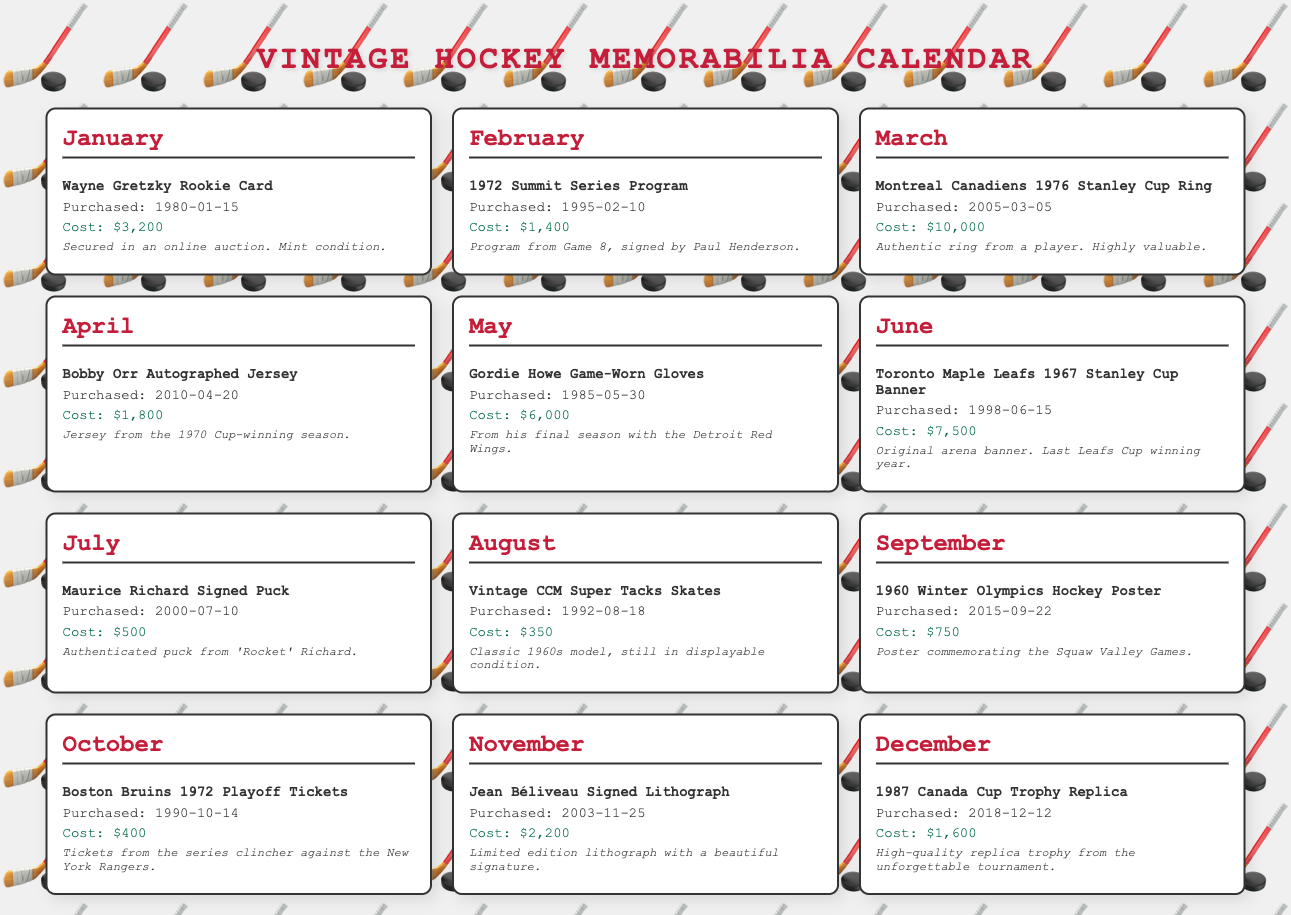What is the most expensive item purchased? The document lists the prices for each item, with the most expensive being the Montreal Canadiens 1976 Stanley Cup Ring for $10,000.
Answer: $10,000 When was the Wayne Gretzky Rookie Card purchased? The document specifies the purchase date for each item; the Wayne Gretzky Rookie Card was purchased on 1980-01-15.
Answer: 1980-01-15 How much did the Gordie Howe Game-Worn Gloves cost? The cost of the Gordie Howe Game-Worn Gloves is explicitly stated in the document as $6,000.
Answer: $6,000 Which month features the Bobby Orr Autographed Jersey? Each item is listed under a specific month; the Bobby Orr Autographed Jersey is in April.
Answer: April What is the total cost of all memorabilia purchased in June? The document presents only one item for June, which is the Toronto Maple Leafs 1967 Stanley Cup Banner costing $7,500, thus no total to calculate.
Answer: $7,500 Which memorabilia item was signed by Paul Henderson? The document indicates that the 1972 Summit Series Program was signed by Paul Henderson.
Answer: 1972 Summit Series Program How many items were purchased in 2010? Reviewing the document reveals there is one item purchased in 2010: the Bobby Orr Autographed Jersey.
Answer: 1 What type of memorabilia is the 1987 Canada Cup Trophy Replica? The document classifies the 1987 Canada Cup Trophy Replica as a high-quality replica trophy.
Answer: Replica trophy 